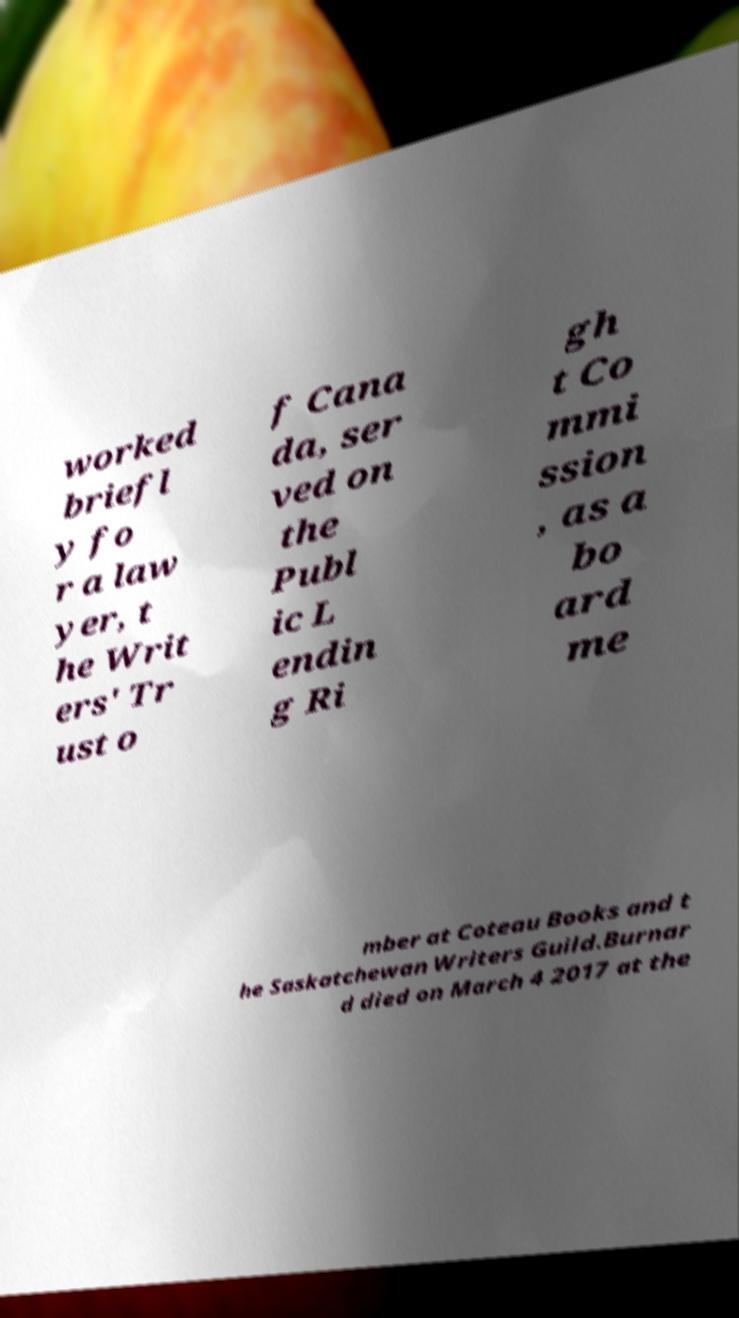I need the written content from this picture converted into text. Can you do that? worked briefl y fo r a law yer, t he Writ ers' Tr ust o f Cana da, ser ved on the Publ ic L endin g Ri gh t Co mmi ssion , as a bo ard me mber at Coteau Books and t he Saskatchewan Writers Guild.Burnar d died on March 4 2017 at the 